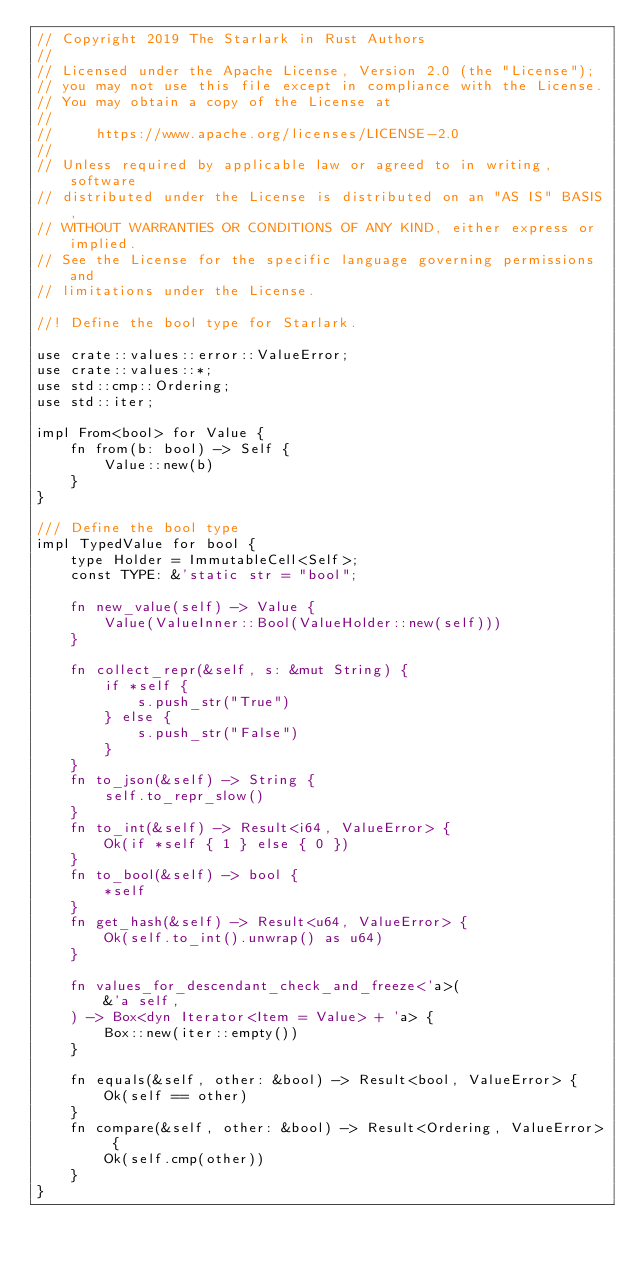Convert code to text. <code><loc_0><loc_0><loc_500><loc_500><_Rust_>// Copyright 2019 The Starlark in Rust Authors
//
// Licensed under the Apache License, Version 2.0 (the "License");
// you may not use this file except in compliance with the License.
// You may obtain a copy of the License at
//
//     https://www.apache.org/licenses/LICENSE-2.0
//
// Unless required by applicable law or agreed to in writing, software
// distributed under the License is distributed on an "AS IS" BASIS,
// WITHOUT WARRANTIES OR CONDITIONS OF ANY KIND, either express or implied.
// See the License for the specific language governing permissions and
// limitations under the License.

//! Define the bool type for Starlark.

use crate::values::error::ValueError;
use crate::values::*;
use std::cmp::Ordering;
use std::iter;

impl From<bool> for Value {
    fn from(b: bool) -> Self {
        Value::new(b)
    }
}

/// Define the bool type
impl TypedValue for bool {
    type Holder = ImmutableCell<Self>;
    const TYPE: &'static str = "bool";

    fn new_value(self) -> Value {
        Value(ValueInner::Bool(ValueHolder::new(self)))
    }

    fn collect_repr(&self, s: &mut String) {
        if *self {
            s.push_str("True")
        } else {
            s.push_str("False")
        }
    }
    fn to_json(&self) -> String {
        self.to_repr_slow()
    }
    fn to_int(&self) -> Result<i64, ValueError> {
        Ok(if *self { 1 } else { 0 })
    }
    fn to_bool(&self) -> bool {
        *self
    }
    fn get_hash(&self) -> Result<u64, ValueError> {
        Ok(self.to_int().unwrap() as u64)
    }

    fn values_for_descendant_check_and_freeze<'a>(
        &'a self,
    ) -> Box<dyn Iterator<Item = Value> + 'a> {
        Box::new(iter::empty())
    }

    fn equals(&self, other: &bool) -> Result<bool, ValueError> {
        Ok(self == other)
    }
    fn compare(&self, other: &bool) -> Result<Ordering, ValueError> {
        Ok(self.cmp(other))
    }
}
</code> 